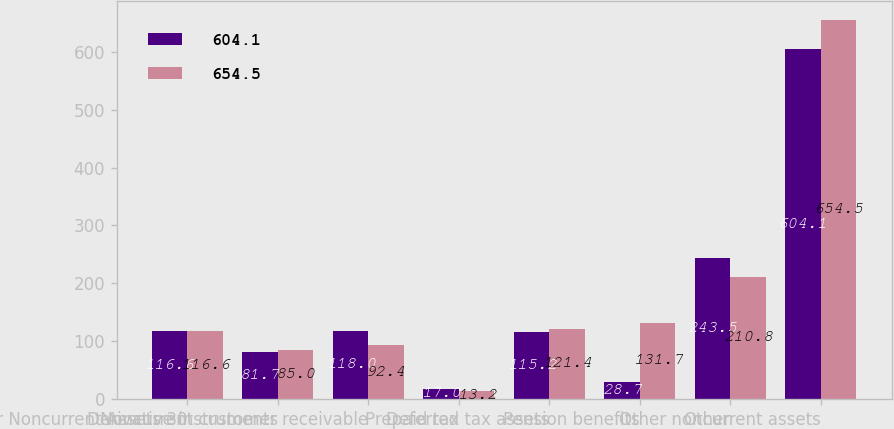<chart> <loc_0><loc_0><loc_500><loc_500><stacked_bar_chart><ecel><fcel>Other Noncurrent Assets 30<fcel>Derivative instruments<fcel>Noncurrent customer receivable<fcel>Prepaid tax<fcel>Deferred tax assets<fcel>Pension benefits<fcel>Other<fcel>Other noncurrent assets<nl><fcel>604.1<fcel>116.6<fcel>81.7<fcel>118<fcel>17<fcel>115.2<fcel>28.7<fcel>243.5<fcel>604.1<nl><fcel>654.5<fcel>116.6<fcel>85<fcel>92.4<fcel>13.2<fcel>121.4<fcel>131.7<fcel>210.8<fcel>654.5<nl></chart> 